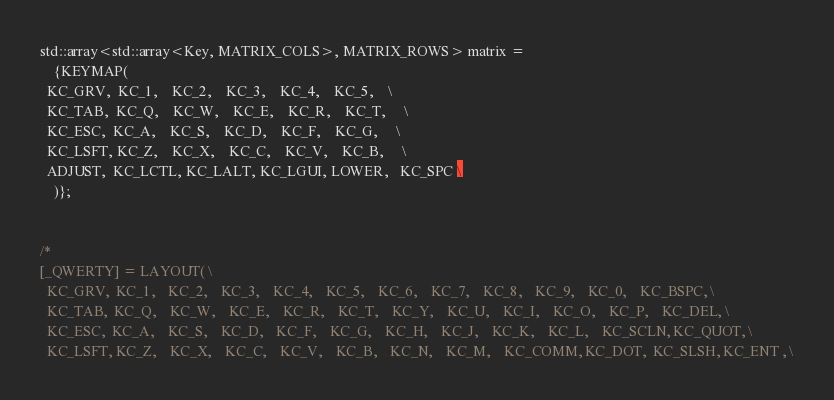Convert code to text. <code><loc_0><loc_0><loc_500><loc_500><_C++_>std::array<std::array<Key, MATRIX_COLS>, MATRIX_ROWS> matrix =
    {KEYMAP(
  KC_GRV,  KC_1,    KC_2,    KC_3,    KC_4,    KC_5,    \
  KC_TAB,  KC_Q,    KC_W,    KC_E,    KC_R,    KC_T,     \
  KC_ESC,  KC_A,    KC_S,    KC_D,    KC_F,    KC_G,     \
  KC_LSFT, KC_Z,    KC_X,    KC_C,    KC_V,    KC_B,     \
  ADJUST,  KC_LCTL, KC_LALT, KC_LGUI, LOWER,   KC_SPC \ 
    )};


/*
[_QWERTY] = LAYOUT( \
  KC_GRV,  KC_1,    KC_2,    KC_3,    KC_4,    KC_5,    KC_6,    KC_7,    KC_8,    KC_9,    KC_0,    KC_BSPC, \
  KC_TAB,  KC_Q,    KC_W,    KC_E,    KC_R,    KC_T,    KC_Y,    KC_U,    KC_I,    KC_O,    KC_P,    KC_DEL, \
  KC_ESC,  KC_A,    KC_S,    KC_D,    KC_F,    KC_G,    KC_H,    KC_J,    KC_K,    KC_L,    KC_SCLN, KC_QUOT, \
  KC_LSFT, KC_Z,    KC_X,    KC_C,    KC_V,    KC_B,    KC_N,    KC_M,    KC_COMM, KC_DOT,  KC_SLSH, KC_ENT , \</code> 